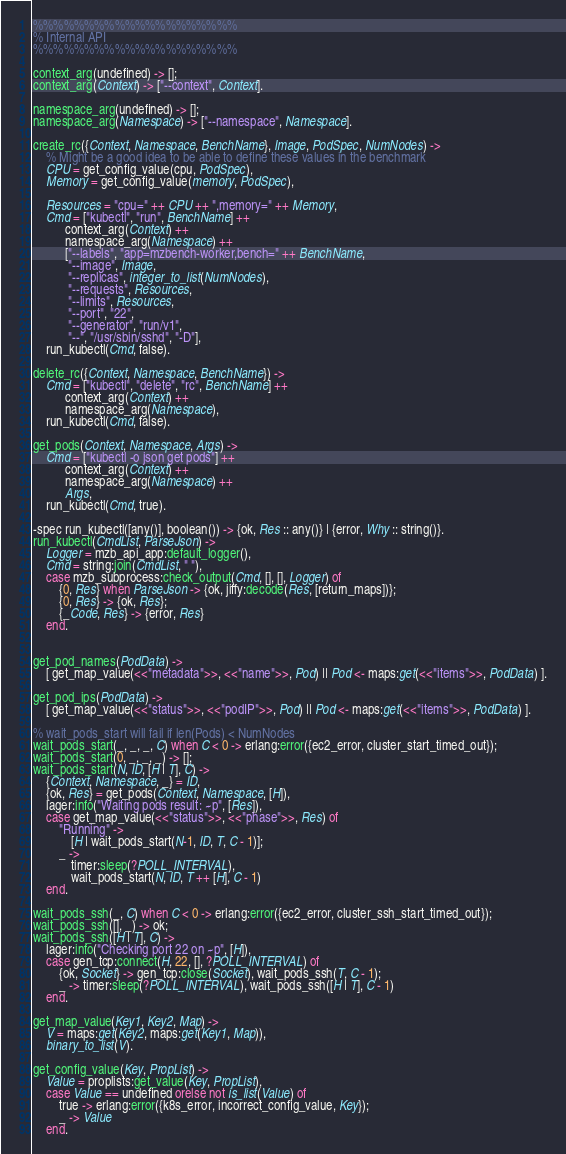<code> <loc_0><loc_0><loc_500><loc_500><_Erlang_>%%%%%%%%%%%%%%%%%%%% 
% Internal API
%%%%%%%%%%%%%%%%%%%% 

context_arg(undefined) -> [];
context_arg(Context) -> ["--context", Context].

namespace_arg(undefined) -> [];
namespace_arg(Namespace) -> ["--namespace", Namespace].

create_rc({Context, Namespace, BenchName}, Image, PodSpec, NumNodes) ->
    % Might be a good idea to be able to define these values in the benchmark
    CPU = get_config_value(cpu, PodSpec),
    Memory = get_config_value(memory, PodSpec),

    Resources = "cpu=" ++ CPU ++ ",memory=" ++ Memory,
    Cmd = ["kubectl", "run", BenchName] ++
          context_arg(Context) ++
          namespace_arg(Namespace) ++
          ["--labels", "app=mzbench-worker,bench=" ++ BenchName,
           "--image", Image,
           "--replicas", integer_to_list(NumNodes),
           "--requests", Resources,
           "--limits", Resources,
           "--port", "22",
           "--generator", "run/v1",
           "--", "/usr/sbin/sshd", "-D"],
    run_kubectl(Cmd, false).

delete_rc({Context, Namespace, BenchName}) ->
    Cmd = ["kubectl", "delete", "rc", BenchName] ++
          context_arg(Context) ++
          namespace_arg(Namespace),
    run_kubectl(Cmd, false).

get_pods(Context, Namespace, Args) ->
    Cmd = ["kubectl -o json get pods"] ++
          context_arg(Context) ++
          namespace_arg(Namespace) ++
          Args,
    run_kubectl(Cmd, true).

-spec run_kubectl([any()], boolean()) -> {ok, Res :: any()} | {error, Why :: string()}.
run_kubectl(CmdList, ParseJson) ->
    Logger = mzb_api_app:default_logger(),
    Cmd = string:join(CmdList, " "),
    case mzb_subprocess:check_output(Cmd, [], [], Logger) of
        {0, Res} when ParseJson -> {ok, jiffy:decode(Res, [return_maps])};
        {0, Res} -> {ok, Res};
        {_Code, Res} -> {error, Res}
    end.


get_pod_names(PodData) -> 
    [ get_map_value(<<"metadata">>, <<"name">>, Pod) || Pod <- maps:get(<<"items">>, PodData) ].

get_pod_ips(PodData) -> 
    [ get_map_value(<<"status">>, <<"podIP">>, Pod) || Pod <- maps:get(<<"items">>, PodData) ].

% wait_pods_start will fail if len(Pods) < NumNodes
wait_pods_start(_, _, _, C) when C < 0 -> erlang:error({ec2_error, cluster_start_timed_out});
wait_pods_start(0, _, _, _) -> [];
wait_pods_start(N, ID, [H | T], C) ->
    {Context, Namespace, _} = ID,
    {ok, Res} = get_pods(Context, Namespace, [H]),
    lager:info("Waiting pods result: ~p", [Res]),
    case get_map_value(<<"status">>, <<"phase">>, Res) of
        "Running" -> 
            [H | wait_pods_start(N-1, ID, T, C - 1)];
        _ -> 
            timer:sleep(?POLL_INTERVAL),
            wait_pods_start(N, ID, T ++ [H], C - 1)
    end.

wait_pods_ssh(_, C) when C < 0 -> erlang:error({ec2_error, cluster_ssh_start_timed_out});
wait_pods_ssh([], _) -> ok;
wait_pods_ssh([H | T], C) ->
    lager:info("Checking port 22 on ~p", [H]),
    case gen_tcp:connect(H, 22, [], ?POLL_INTERVAL) of
        {ok, Socket} -> gen_tcp:close(Socket), wait_pods_ssh(T, C - 1);
        _ -> timer:sleep(?POLL_INTERVAL), wait_pods_ssh([H | T], C - 1)
    end.

get_map_value(Key1, Key2, Map) ->
    V = maps:get(Key2, maps:get(Key1, Map)),
    binary_to_list(V).

get_config_value(Key, PropList) ->
    Value = proplists:get_value(Key, PropList),
    case Value == undefined orelse not is_list(Value) of
        true -> erlang:error({k8s_error, incorrect_config_value, Key});
        _ -> Value
    end.
</code> 